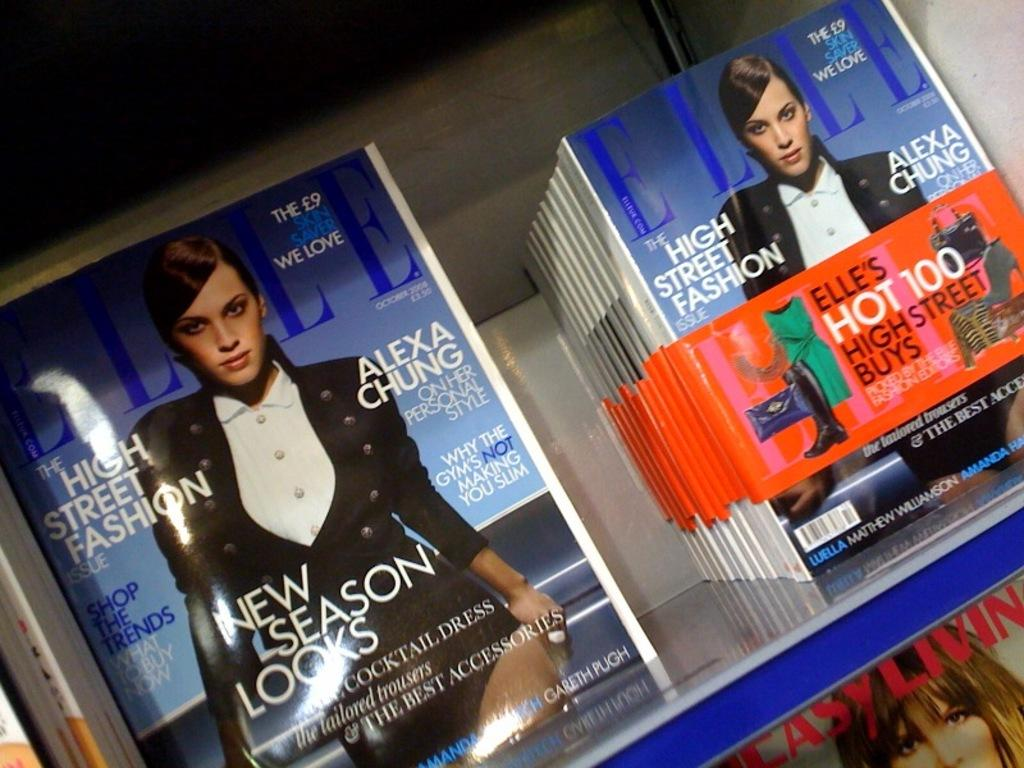<image>
Describe the image concisely. Two stacks of Elle magazine featuring Alexa Chung. 